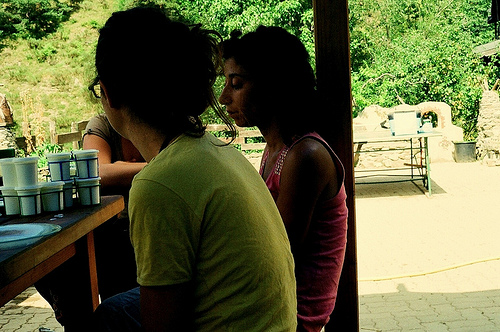<image>
Is the girl on the pole? No. The girl is not positioned on the pole. They may be near each other, but the girl is not supported by or resting on top of the pole. Is there a woman behind the man? No. The woman is not behind the man. From this viewpoint, the woman appears to be positioned elsewhere in the scene. Is there a woman to the right of the woman? Yes. From this viewpoint, the woman is positioned to the right side relative to the woman. 